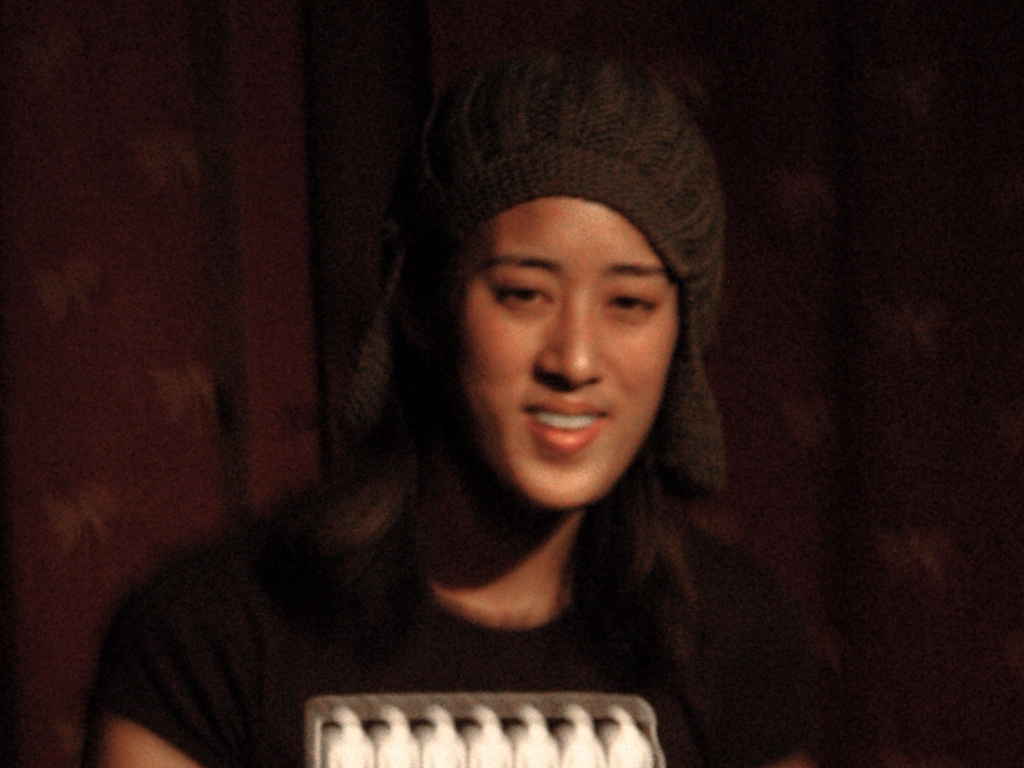Are there any quality issues with this image? Yes, there are several quality issues with this image. Firstly, the image is notably blurry, which obscures fine details. Secondly, there is significant digital noise or grain throughout the picture, likely due to a high ISO setting or low light conditions when the photo was taken. Additionally, the lighting seems unbalanced, with the subject's face being shadowed, which results in a loss of detail in the facial features. 